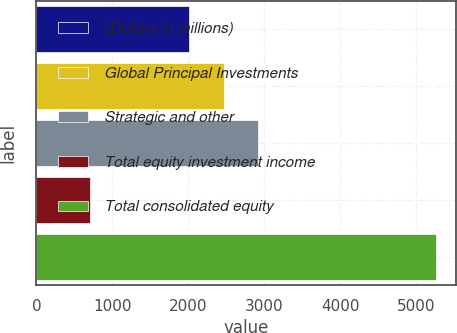Convert chart. <chart><loc_0><loc_0><loc_500><loc_500><bar_chart><fcel>(Dollars in millions)<fcel>Global Principal Investments<fcel>Strategic and other<fcel>Total equity investment income<fcel>Total consolidated equity<nl><fcel>2010<fcel>2464.9<fcel>2919.8<fcel>711<fcel>5260<nl></chart> 